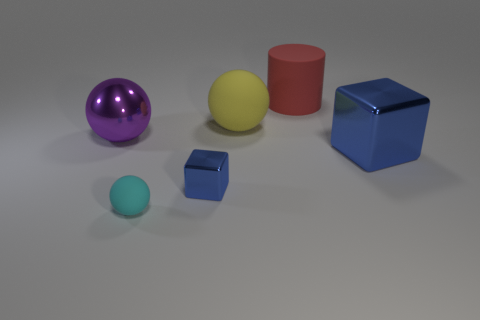Add 2 brown spheres. How many objects exist? 8 Subtract all matte spheres. How many spheres are left? 1 Subtract all yellow balls. How many balls are left? 2 Add 6 blocks. How many blocks are left? 8 Add 4 tiny gray cylinders. How many tiny gray cylinders exist? 4 Subtract 0 gray blocks. How many objects are left? 6 Subtract all cubes. How many objects are left? 4 Subtract 1 spheres. How many spheres are left? 2 Subtract all purple blocks. Subtract all yellow spheres. How many blocks are left? 2 Subtract all gray cylinders. How many yellow balls are left? 1 